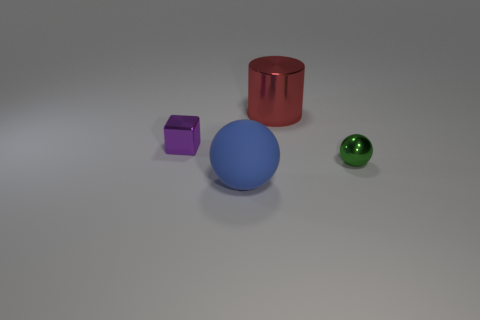Add 1 red cylinders. How many objects exist? 5 Subtract all cylinders. How many objects are left? 3 Subtract 0 cyan cylinders. How many objects are left? 4 Subtract all rubber cylinders. Subtract all green things. How many objects are left? 3 Add 4 purple blocks. How many purple blocks are left? 5 Add 1 small purple shiny things. How many small purple shiny things exist? 2 